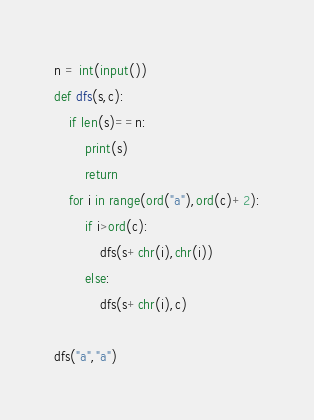<code> <loc_0><loc_0><loc_500><loc_500><_Python_>n = int(input())
def dfs(s,c):
    if len(s)==n:
        print(s)
        return
    for i in range(ord("a"),ord(c)+2):
        if i>ord(c):
            dfs(s+chr(i),chr(i))
        else:
            dfs(s+chr(i),c)

dfs("a","a")</code> 